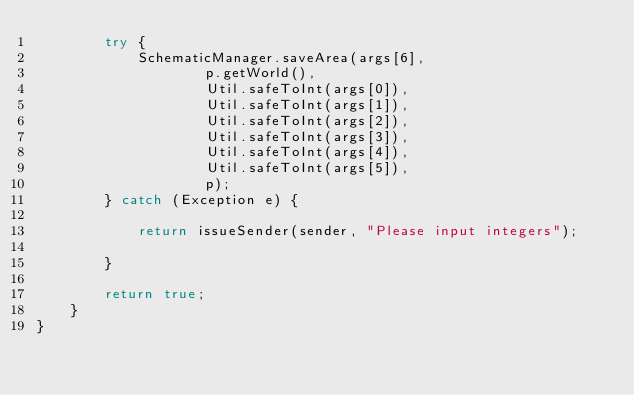<code> <loc_0><loc_0><loc_500><loc_500><_Java_>        try {
            SchematicManager.saveArea(args[6],
                    p.getWorld(),
                    Util.safeToInt(args[0]),
                    Util.safeToInt(args[1]),
                    Util.safeToInt(args[2]),
                    Util.safeToInt(args[3]),
                    Util.safeToInt(args[4]),
                    Util.safeToInt(args[5]),
                    p);
        } catch (Exception e) {

            return issueSender(sender, "Please input integers");

        }

        return true;
    }
}
</code> 